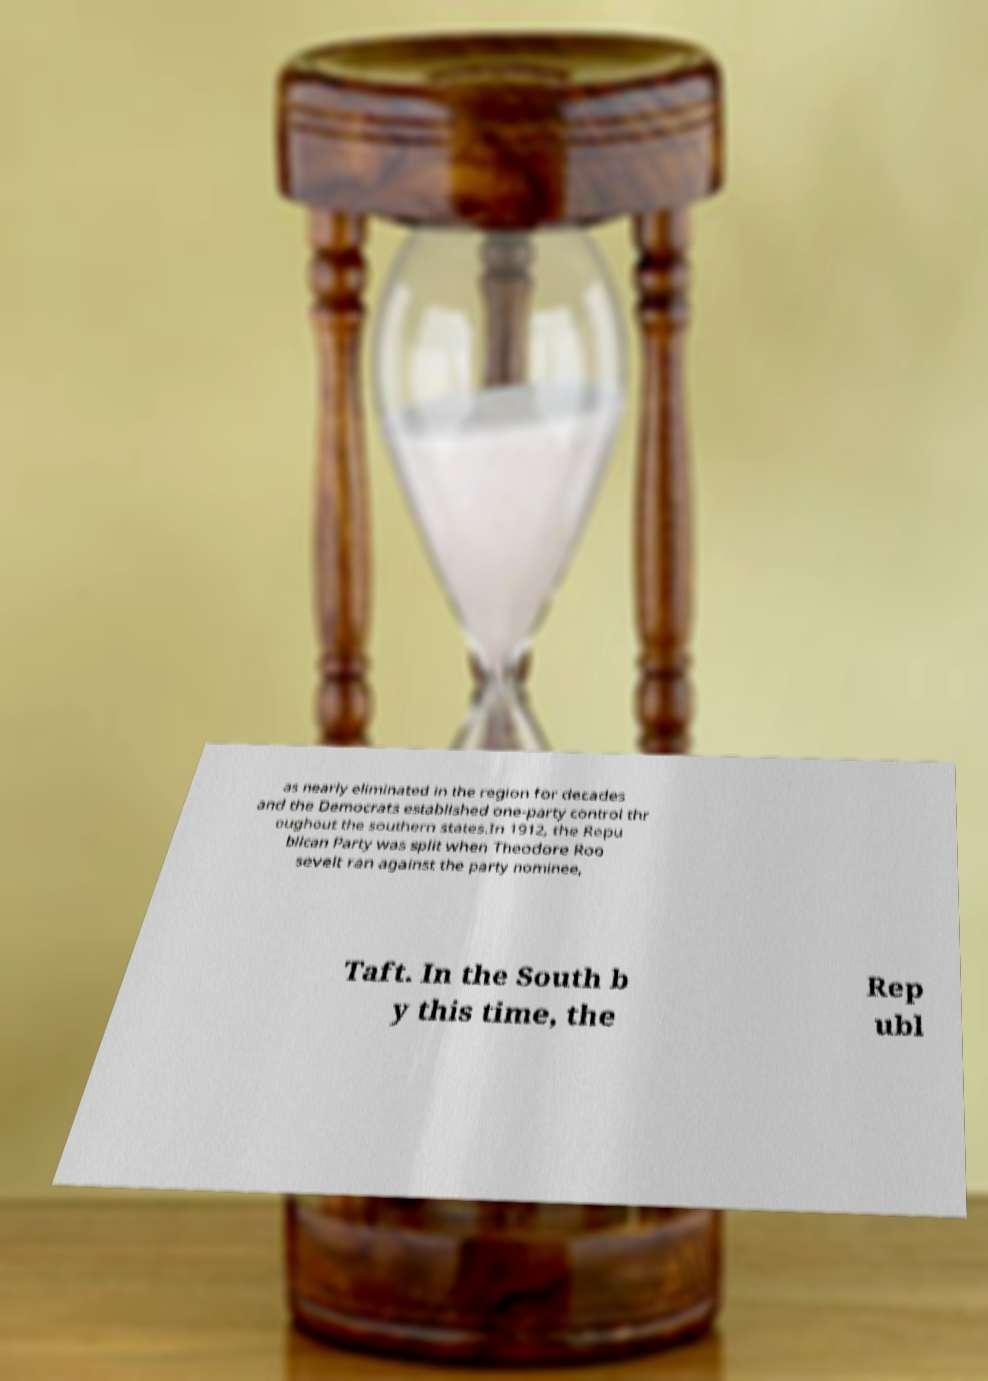What messages or text are displayed in this image? I need them in a readable, typed format. as nearly eliminated in the region for decades and the Democrats established one-party control thr oughout the southern states.In 1912, the Repu blican Party was split when Theodore Roo sevelt ran against the party nominee, Taft. In the South b y this time, the Rep ubl 